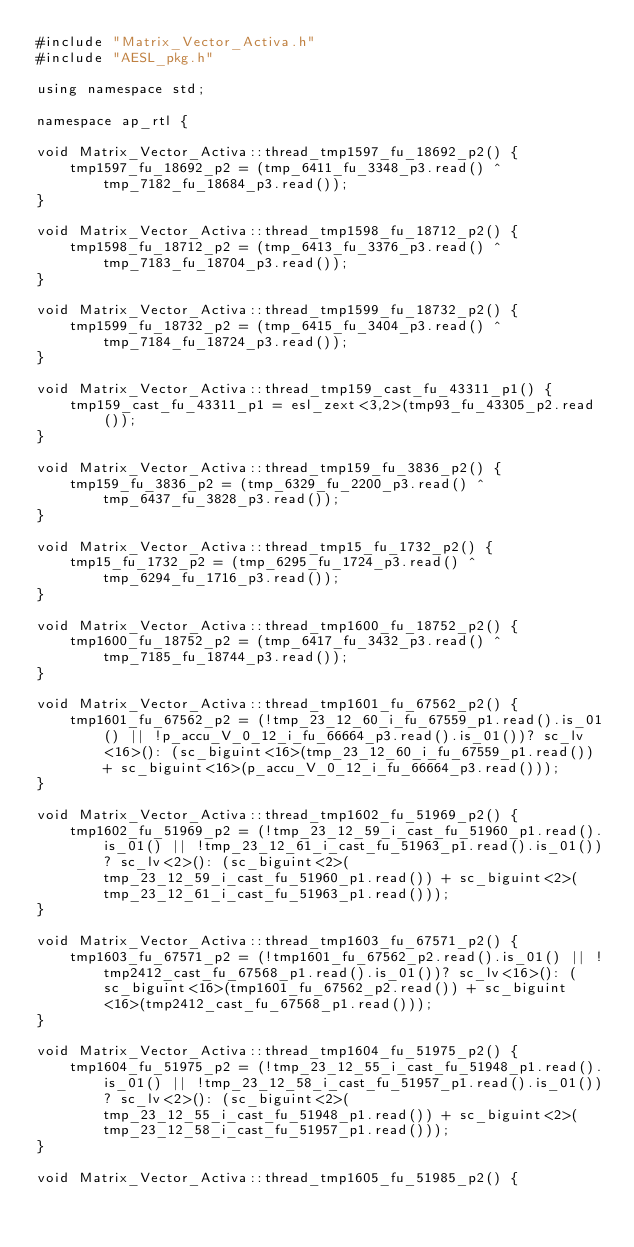<code> <loc_0><loc_0><loc_500><loc_500><_C++_>#include "Matrix_Vector_Activa.h"
#include "AESL_pkg.h"

using namespace std;

namespace ap_rtl {

void Matrix_Vector_Activa::thread_tmp1597_fu_18692_p2() {
    tmp1597_fu_18692_p2 = (tmp_6411_fu_3348_p3.read() ^ tmp_7182_fu_18684_p3.read());
}

void Matrix_Vector_Activa::thread_tmp1598_fu_18712_p2() {
    tmp1598_fu_18712_p2 = (tmp_6413_fu_3376_p3.read() ^ tmp_7183_fu_18704_p3.read());
}

void Matrix_Vector_Activa::thread_tmp1599_fu_18732_p2() {
    tmp1599_fu_18732_p2 = (tmp_6415_fu_3404_p3.read() ^ tmp_7184_fu_18724_p3.read());
}

void Matrix_Vector_Activa::thread_tmp159_cast_fu_43311_p1() {
    tmp159_cast_fu_43311_p1 = esl_zext<3,2>(tmp93_fu_43305_p2.read());
}

void Matrix_Vector_Activa::thread_tmp159_fu_3836_p2() {
    tmp159_fu_3836_p2 = (tmp_6329_fu_2200_p3.read() ^ tmp_6437_fu_3828_p3.read());
}

void Matrix_Vector_Activa::thread_tmp15_fu_1732_p2() {
    tmp15_fu_1732_p2 = (tmp_6295_fu_1724_p3.read() ^ tmp_6294_fu_1716_p3.read());
}

void Matrix_Vector_Activa::thread_tmp1600_fu_18752_p2() {
    tmp1600_fu_18752_p2 = (tmp_6417_fu_3432_p3.read() ^ tmp_7185_fu_18744_p3.read());
}

void Matrix_Vector_Activa::thread_tmp1601_fu_67562_p2() {
    tmp1601_fu_67562_p2 = (!tmp_23_12_60_i_fu_67559_p1.read().is_01() || !p_accu_V_0_12_i_fu_66664_p3.read().is_01())? sc_lv<16>(): (sc_biguint<16>(tmp_23_12_60_i_fu_67559_p1.read()) + sc_biguint<16>(p_accu_V_0_12_i_fu_66664_p3.read()));
}

void Matrix_Vector_Activa::thread_tmp1602_fu_51969_p2() {
    tmp1602_fu_51969_p2 = (!tmp_23_12_59_i_cast_fu_51960_p1.read().is_01() || !tmp_23_12_61_i_cast_fu_51963_p1.read().is_01())? sc_lv<2>(): (sc_biguint<2>(tmp_23_12_59_i_cast_fu_51960_p1.read()) + sc_biguint<2>(tmp_23_12_61_i_cast_fu_51963_p1.read()));
}

void Matrix_Vector_Activa::thread_tmp1603_fu_67571_p2() {
    tmp1603_fu_67571_p2 = (!tmp1601_fu_67562_p2.read().is_01() || !tmp2412_cast_fu_67568_p1.read().is_01())? sc_lv<16>(): (sc_biguint<16>(tmp1601_fu_67562_p2.read()) + sc_biguint<16>(tmp2412_cast_fu_67568_p1.read()));
}

void Matrix_Vector_Activa::thread_tmp1604_fu_51975_p2() {
    tmp1604_fu_51975_p2 = (!tmp_23_12_55_i_cast_fu_51948_p1.read().is_01() || !tmp_23_12_58_i_cast_fu_51957_p1.read().is_01())? sc_lv<2>(): (sc_biguint<2>(tmp_23_12_55_i_cast_fu_51948_p1.read()) + sc_biguint<2>(tmp_23_12_58_i_cast_fu_51957_p1.read()));
}

void Matrix_Vector_Activa::thread_tmp1605_fu_51985_p2() {</code> 